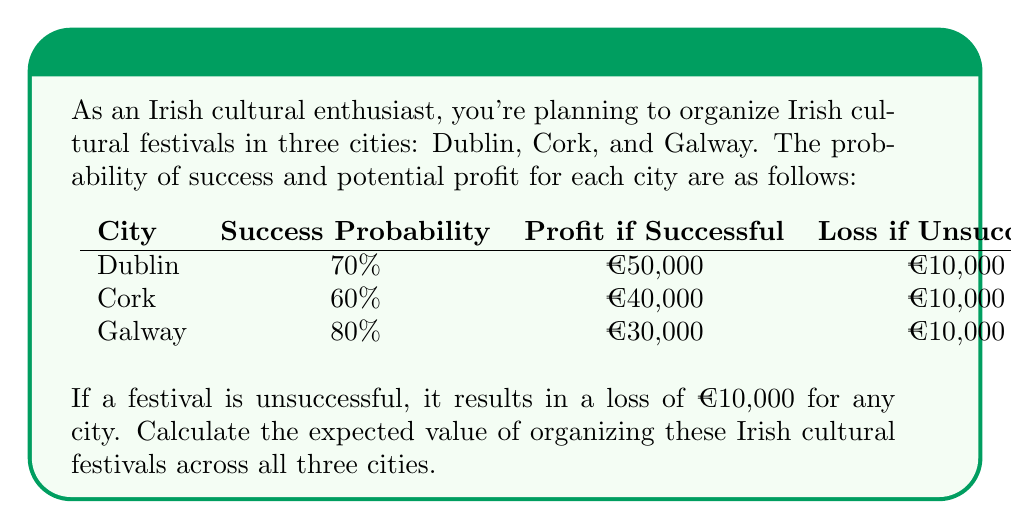Could you help me with this problem? To calculate the expected value, we need to follow these steps for each city:

1. Calculate the expected value of success:
   (Probability of success) × (Profit if successful)
2. Calculate the expected value of failure:
   (Probability of failure) × (Loss if unsuccessful)
3. Sum the expected values of success and failure

Let's calculate for each city:

Dublin:
1. Expected value of success: $0.70 \times €50,000 = €35,000$
2. Expected value of failure: $0.30 \times (-€10,000) = -€3,000$
3. Total expected value: $€35,000 + (-€3,000) = €32,000$

Cork:
1. Expected value of success: $0.60 \times €40,000 = €24,000$
2. Expected value of failure: $0.40 \times (-€10,000) = -€4,000$
3. Total expected value: $€24,000 + (-€4,000) = €20,000$

Galway:
1. Expected value of success: $0.80 \times €30,000 = €24,000$
2. Expected value of failure: $0.20 \times (-€10,000) = -€2,000$
3. Total expected value: $€24,000 + (-€2,000) = €22,000$

Now, we sum the expected values for all three cities:

$€32,000 + €20,000 + €22,000 = €74,000$

Therefore, the total expected value of organizing Irish cultural festivals across all three cities is €74,000.
Answer: €74,000 